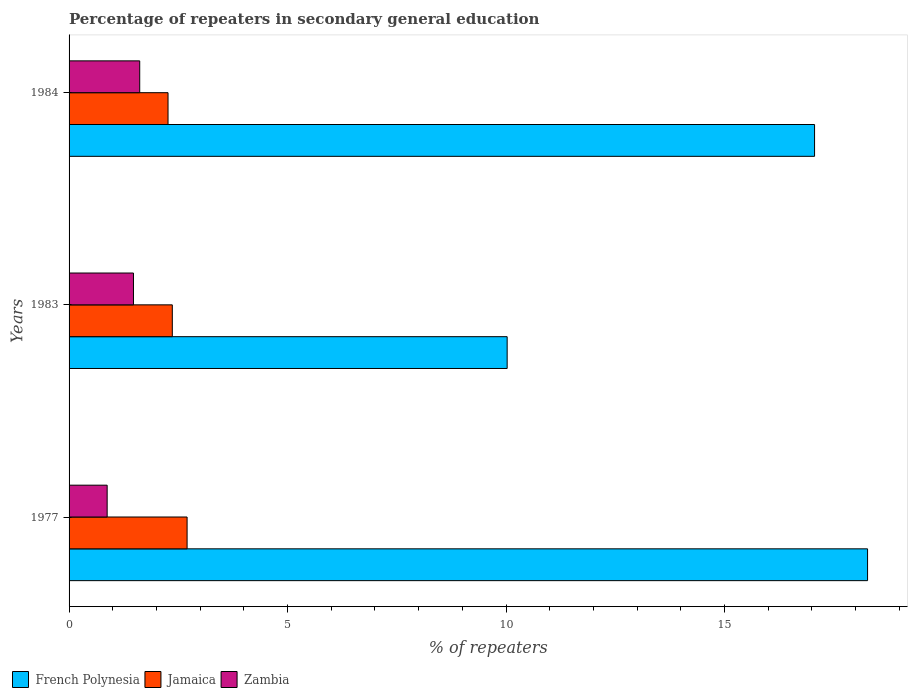How many different coloured bars are there?
Ensure brevity in your answer.  3. How many groups of bars are there?
Give a very brief answer. 3. Are the number of bars per tick equal to the number of legend labels?
Your response must be concise. Yes. Are the number of bars on each tick of the Y-axis equal?
Ensure brevity in your answer.  Yes. How many bars are there on the 2nd tick from the top?
Offer a very short reply. 3. How many bars are there on the 2nd tick from the bottom?
Give a very brief answer. 3. What is the label of the 1st group of bars from the top?
Provide a succinct answer. 1984. In how many cases, is the number of bars for a given year not equal to the number of legend labels?
Your response must be concise. 0. What is the percentage of repeaters in secondary general education in Jamaica in 1984?
Your response must be concise. 2.26. Across all years, what is the maximum percentage of repeaters in secondary general education in Zambia?
Keep it short and to the point. 1.62. Across all years, what is the minimum percentage of repeaters in secondary general education in Jamaica?
Offer a terse response. 2.26. In which year was the percentage of repeaters in secondary general education in Zambia maximum?
Make the answer very short. 1984. What is the total percentage of repeaters in secondary general education in French Polynesia in the graph?
Make the answer very short. 45.36. What is the difference between the percentage of repeaters in secondary general education in Zambia in 1977 and that in 1983?
Keep it short and to the point. -0.6. What is the difference between the percentage of repeaters in secondary general education in Jamaica in 1977 and the percentage of repeaters in secondary general education in French Polynesia in 1983?
Your answer should be very brief. -7.32. What is the average percentage of repeaters in secondary general education in Jamaica per year?
Offer a very short reply. 2.44. In the year 1983, what is the difference between the percentage of repeaters in secondary general education in Zambia and percentage of repeaters in secondary general education in Jamaica?
Your answer should be very brief. -0.89. What is the ratio of the percentage of repeaters in secondary general education in Zambia in 1977 to that in 1984?
Your response must be concise. 0.54. Is the difference between the percentage of repeaters in secondary general education in Zambia in 1977 and 1983 greater than the difference between the percentage of repeaters in secondary general education in Jamaica in 1977 and 1983?
Offer a very short reply. No. What is the difference between the highest and the second highest percentage of repeaters in secondary general education in Zambia?
Your answer should be very brief. 0.14. What is the difference between the highest and the lowest percentage of repeaters in secondary general education in Zambia?
Ensure brevity in your answer.  0.75. In how many years, is the percentage of repeaters in secondary general education in Jamaica greater than the average percentage of repeaters in secondary general education in Jamaica taken over all years?
Make the answer very short. 1. Is the sum of the percentage of repeaters in secondary general education in French Polynesia in 1977 and 1983 greater than the maximum percentage of repeaters in secondary general education in Jamaica across all years?
Give a very brief answer. Yes. What does the 1st bar from the top in 1977 represents?
Your answer should be compact. Zambia. What does the 1st bar from the bottom in 1977 represents?
Your response must be concise. French Polynesia. How many bars are there?
Provide a short and direct response. 9. Does the graph contain any zero values?
Give a very brief answer. No. Does the graph contain grids?
Make the answer very short. No. Where does the legend appear in the graph?
Offer a terse response. Bottom left. How are the legend labels stacked?
Your answer should be compact. Horizontal. What is the title of the graph?
Offer a terse response. Percentage of repeaters in secondary general education. Does "Hong Kong" appear as one of the legend labels in the graph?
Provide a short and direct response. No. What is the label or title of the X-axis?
Keep it short and to the point. % of repeaters. What is the label or title of the Y-axis?
Your answer should be very brief. Years. What is the % of repeaters of French Polynesia in 1977?
Your answer should be very brief. 18.27. What is the % of repeaters of Jamaica in 1977?
Make the answer very short. 2.7. What is the % of repeaters of Zambia in 1977?
Offer a terse response. 0.87. What is the % of repeaters of French Polynesia in 1983?
Provide a short and direct response. 10.03. What is the % of repeaters in Jamaica in 1983?
Your answer should be compact. 2.36. What is the % of repeaters of Zambia in 1983?
Your response must be concise. 1.47. What is the % of repeaters of French Polynesia in 1984?
Your answer should be compact. 17.06. What is the % of repeaters in Jamaica in 1984?
Keep it short and to the point. 2.26. What is the % of repeaters in Zambia in 1984?
Provide a short and direct response. 1.62. Across all years, what is the maximum % of repeaters of French Polynesia?
Your response must be concise. 18.27. Across all years, what is the maximum % of repeaters in Jamaica?
Your answer should be very brief. 2.7. Across all years, what is the maximum % of repeaters of Zambia?
Provide a short and direct response. 1.62. Across all years, what is the minimum % of repeaters of French Polynesia?
Ensure brevity in your answer.  10.03. Across all years, what is the minimum % of repeaters of Jamaica?
Make the answer very short. 2.26. Across all years, what is the minimum % of repeaters in Zambia?
Your answer should be very brief. 0.87. What is the total % of repeaters of French Polynesia in the graph?
Offer a very short reply. 45.36. What is the total % of repeaters in Jamaica in the graph?
Give a very brief answer. 7.33. What is the total % of repeaters in Zambia in the graph?
Your answer should be very brief. 3.96. What is the difference between the % of repeaters of French Polynesia in 1977 and that in 1983?
Your response must be concise. 8.25. What is the difference between the % of repeaters in Jamaica in 1977 and that in 1983?
Provide a succinct answer. 0.34. What is the difference between the % of repeaters of Zambia in 1977 and that in 1983?
Ensure brevity in your answer.  -0.6. What is the difference between the % of repeaters of French Polynesia in 1977 and that in 1984?
Ensure brevity in your answer.  1.21. What is the difference between the % of repeaters in Jamaica in 1977 and that in 1984?
Offer a terse response. 0.44. What is the difference between the % of repeaters in Zambia in 1977 and that in 1984?
Your response must be concise. -0.75. What is the difference between the % of repeaters of French Polynesia in 1983 and that in 1984?
Make the answer very short. -7.03. What is the difference between the % of repeaters in Jamaica in 1983 and that in 1984?
Make the answer very short. 0.1. What is the difference between the % of repeaters in Zambia in 1983 and that in 1984?
Give a very brief answer. -0.14. What is the difference between the % of repeaters of French Polynesia in 1977 and the % of repeaters of Jamaica in 1983?
Make the answer very short. 15.91. What is the difference between the % of repeaters of French Polynesia in 1977 and the % of repeaters of Zambia in 1983?
Offer a terse response. 16.8. What is the difference between the % of repeaters of Jamaica in 1977 and the % of repeaters of Zambia in 1983?
Make the answer very short. 1.23. What is the difference between the % of repeaters in French Polynesia in 1977 and the % of repeaters in Jamaica in 1984?
Offer a very short reply. 16.01. What is the difference between the % of repeaters in French Polynesia in 1977 and the % of repeaters in Zambia in 1984?
Give a very brief answer. 16.66. What is the difference between the % of repeaters in Jamaica in 1977 and the % of repeaters in Zambia in 1984?
Offer a terse response. 1.08. What is the difference between the % of repeaters of French Polynesia in 1983 and the % of repeaters of Jamaica in 1984?
Make the answer very short. 7.76. What is the difference between the % of repeaters of French Polynesia in 1983 and the % of repeaters of Zambia in 1984?
Provide a succinct answer. 8.41. What is the difference between the % of repeaters of Jamaica in 1983 and the % of repeaters of Zambia in 1984?
Offer a very short reply. 0.75. What is the average % of repeaters in French Polynesia per year?
Provide a succinct answer. 15.12. What is the average % of repeaters in Jamaica per year?
Offer a very short reply. 2.44. What is the average % of repeaters in Zambia per year?
Your answer should be compact. 1.32. In the year 1977, what is the difference between the % of repeaters of French Polynesia and % of repeaters of Jamaica?
Your answer should be compact. 15.57. In the year 1977, what is the difference between the % of repeaters of French Polynesia and % of repeaters of Zambia?
Your answer should be very brief. 17.4. In the year 1977, what is the difference between the % of repeaters of Jamaica and % of repeaters of Zambia?
Make the answer very short. 1.83. In the year 1983, what is the difference between the % of repeaters in French Polynesia and % of repeaters in Jamaica?
Your answer should be very brief. 7.66. In the year 1983, what is the difference between the % of repeaters in French Polynesia and % of repeaters in Zambia?
Give a very brief answer. 8.55. In the year 1984, what is the difference between the % of repeaters of French Polynesia and % of repeaters of Jamaica?
Offer a very short reply. 14.8. In the year 1984, what is the difference between the % of repeaters of French Polynesia and % of repeaters of Zambia?
Offer a very short reply. 15.44. In the year 1984, what is the difference between the % of repeaters in Jamaica and % of repeaters in Zambia?
Make the answer very short. 0.65. What is the ratio of the % of repeaters of French Polynesia in 1977 to that in 1983?
Your answer should be compact. 1.82. What is the ratio of the % of repeaters of Jamaica in 1977 to that in 1983?
Your answer should be very brief. 1.14. What is the ratio of the % of repeaters in Zambia in 1977 to that in 1983?
Give a very brief answer. 0.59. What is the ratio of the % of repeaters in French Polynesia in 1977 to that in 1984?
Your answer should be very brief. 1.07. What is the ratio of the % of repeaters of Jamaica in 1977 to that in 1984?
Ensure brevity in your answer.  1.19. What is the ratio of the % of repeaters of Zambia in 1977 to that in 1984?
Keep it short and to the point. 0.54. What is the ratio of the % of repeaters in French Polynesia in 1983 to that in 1984?
Keep it short and to the point. 0.59. What is the ratio of the % of repeaters of Jamaica in 1983 to that in 1984?
Keep it short and to the point. 1.04. What is the ratio of the % of repeaters in Zambia in 1983 to that in 1984?
Your answer should be compact. 0.91. What is the difference between the highest and the second highest % of repeaters of French Polynesia?
Ensure brevity in your answer.  1.21. What is the difference between the highest and the second highest % of repeaters in Jamaica?
Provide a succinct answer. 0.34. What is the difference between the highest and the second highest % of repeaters of Zambia?
Offer a very short reply. 0.14. What is the difference between the highest and the lowest % of repeaters in French Polynesia?
Offer a terse response. 8.25. What is the difference between the highest and the lowest % of repeaters in Jamaica?
Your answer should be very brief. 0.44. What is the difference between the highest and the lowest % of repeaters in Zambia?
Your response must be concise. 0.75. 